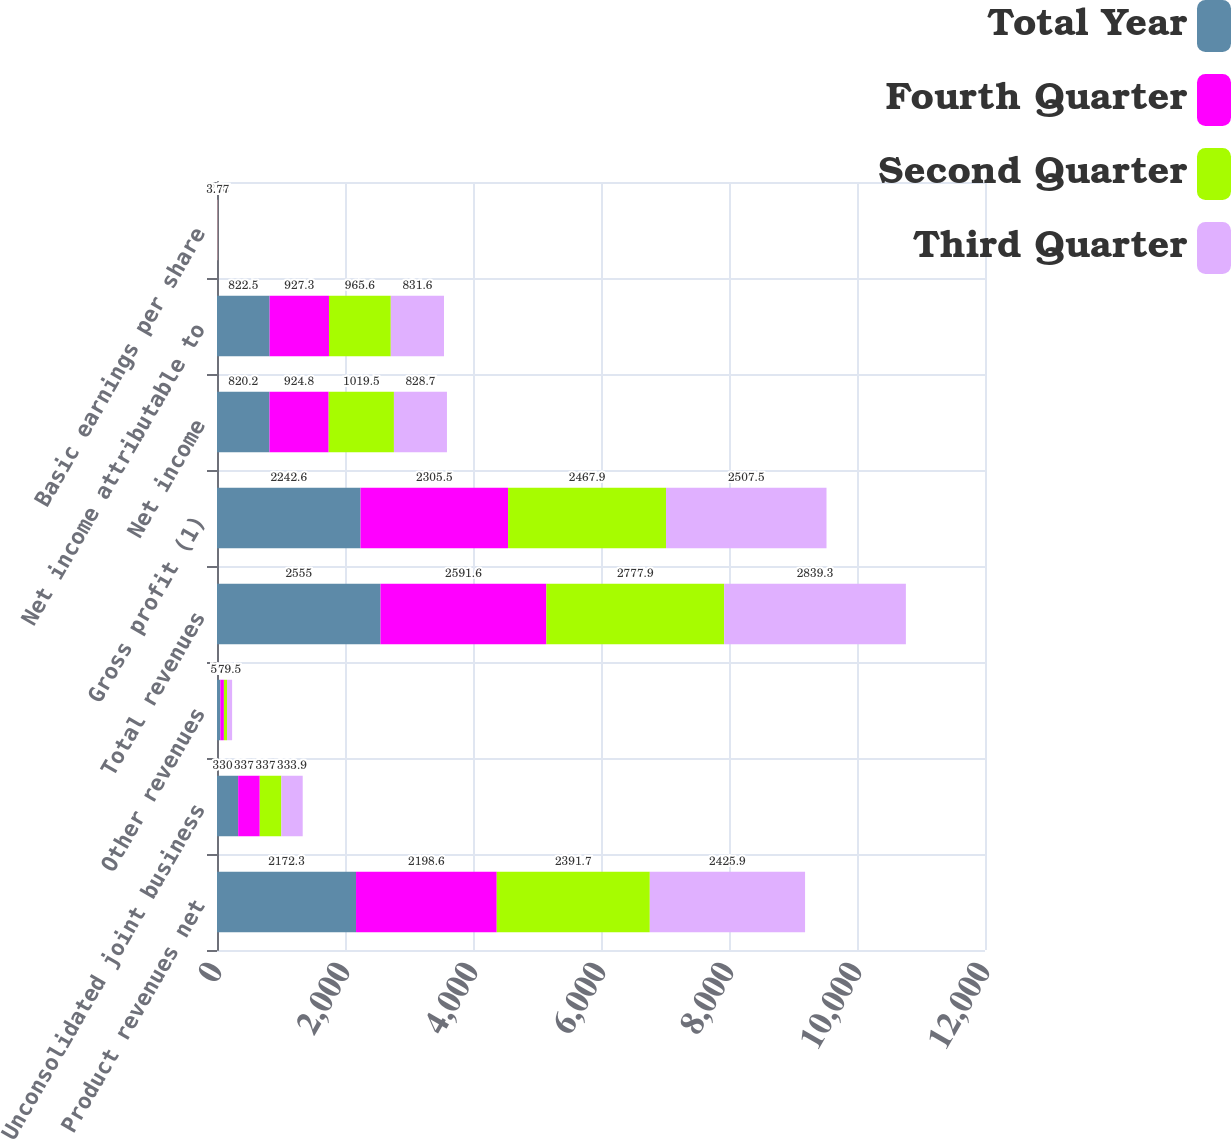Convert chart to OTSL. <chart><loc_0><loc_0><loc_500><loc_500><stacked_bar_chart><ecel><fcel>Product revenues net<fcel>Unconsolidated joint business<fcel>Other revenues<fcel>Total revenues<fcel>Gross profit (1)<fcel>Net income<fcel>Net income attributable to<fcel>Basic earnings per share<nl><fcel>Total Year<fcel>2172.3<fcel>330.6<fcel>52<fcel>2555<fcel>2242.6<fcel>820.2<fcel>822.5<fcel>3.5<nl><fcel>Fourth Quarter<fcel>2198.6<fcel>337.5<fcel>55.6<fcel>2591.6<fcel>2305.5<fcel>924.8<fcel>927.3<fcel>3.94<nl><fcel>Second Quarter<fcel>2391.7<fcel>337.2<fcel>49<fcel>2777.9<fcel>2467.9<fcel>1019.5<fcel>965.6<fcel>4.16<nl><fcel>Third Quarter<fcel>2425.9<fcel>333.9<fcel>79.5<fcel>2839.3<fcel>2507.5<fcel>828.7<fcel>831.6<fcel>3.77<nl></chart> 